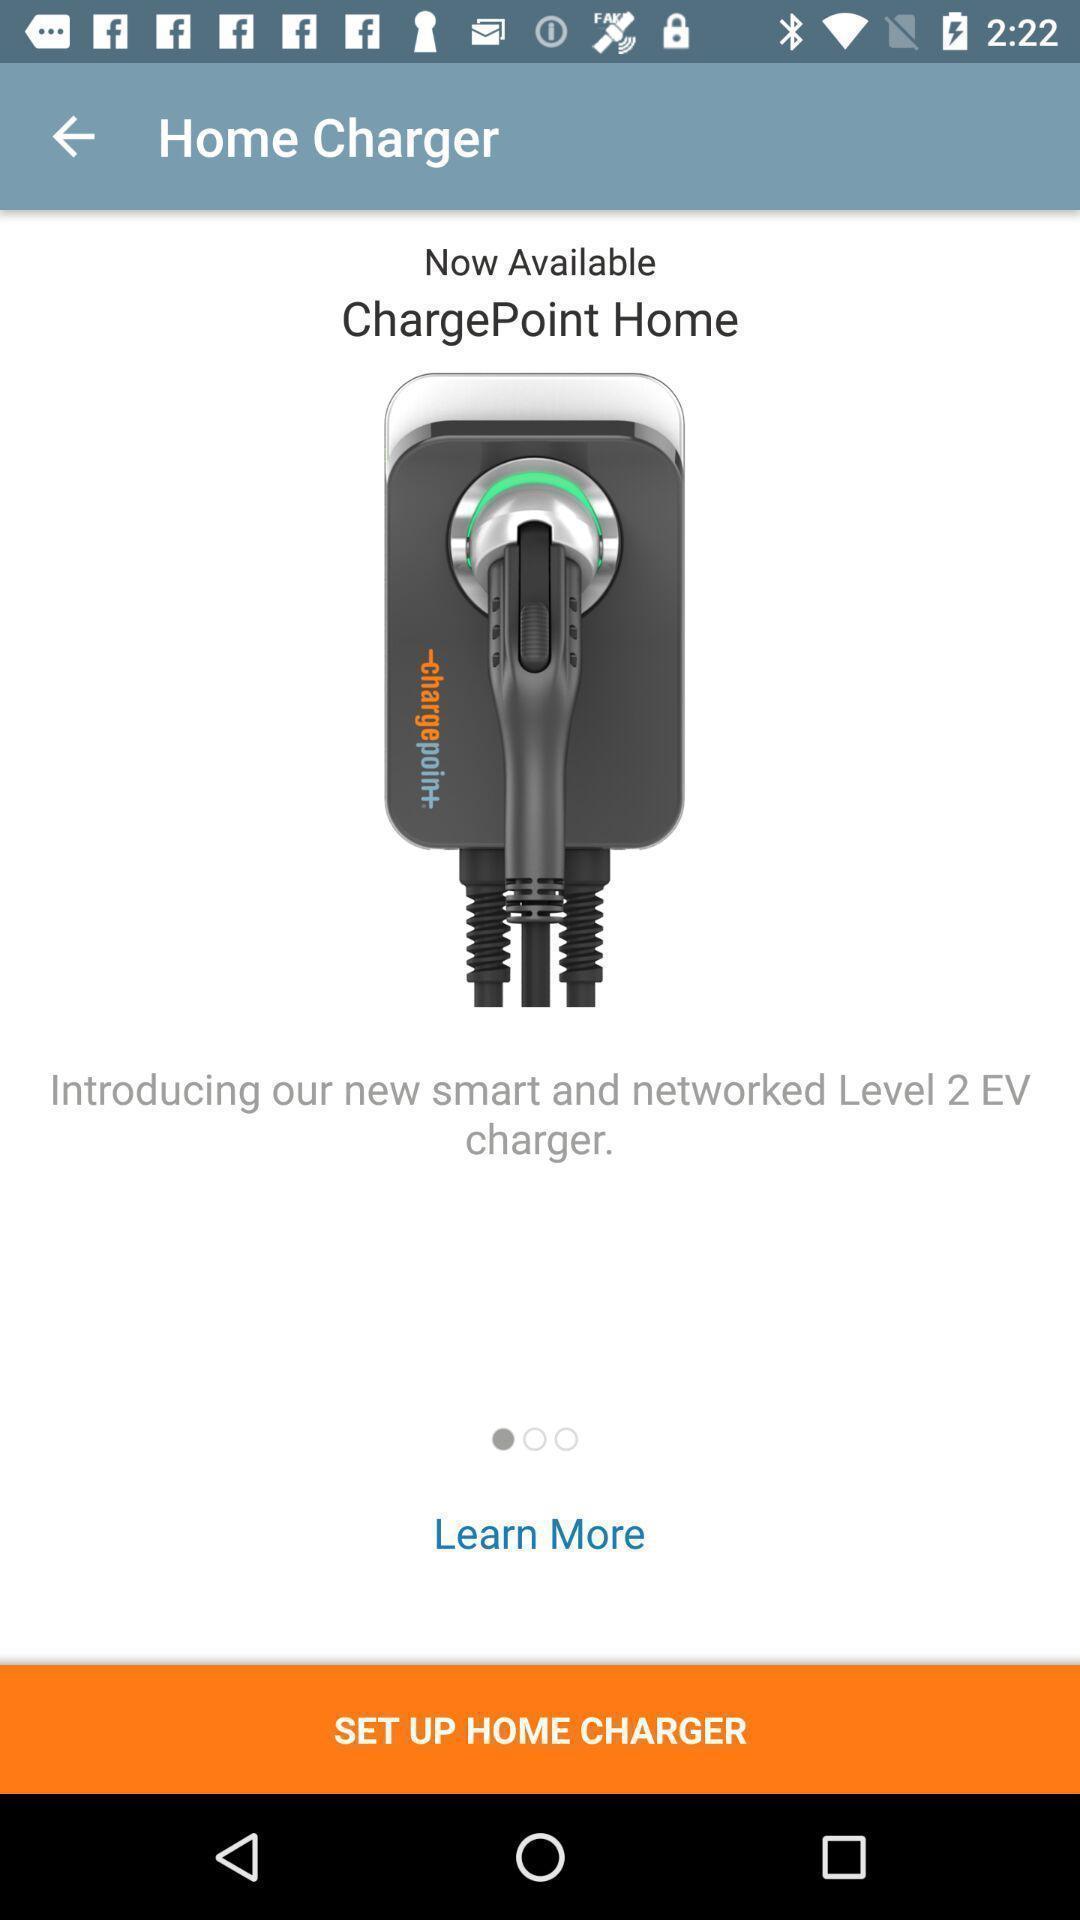What details can you identify in this image? Welcome page. 